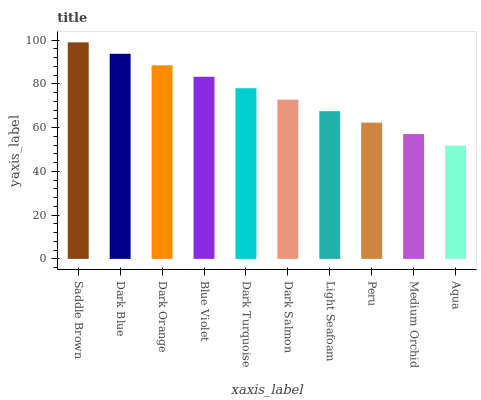Is Aqua the minimum?
Answer yes or no. Yes. Is Saddle Brown the maximum?
Answer yes or no. Yes. Is Dark Blue the minimum?
Answer yes or no. No. Is Dark Blue the maximum?
Answer yes or no. No. Is Saddle Brown greater than Dark Blue?
Answer yes or no. Yes. Is Dark Blue less than Saddle Brown?
Answer yes or no. Yes. Is Dark Blue greater than Saddle Brown?
Answer yes or no. No. Is Saddle Brown less than Dark Blue?
Answer yes or no. No. Is Dark Turquoise the high median?
Answer yes or no. Yes. Is Dark Salmon the low median?
Answer yes or no. Yes. Is Dark Salmon the high median?
Answer yes or no. No. Is Dark Blue the low median?
Answer yes or no. No. 